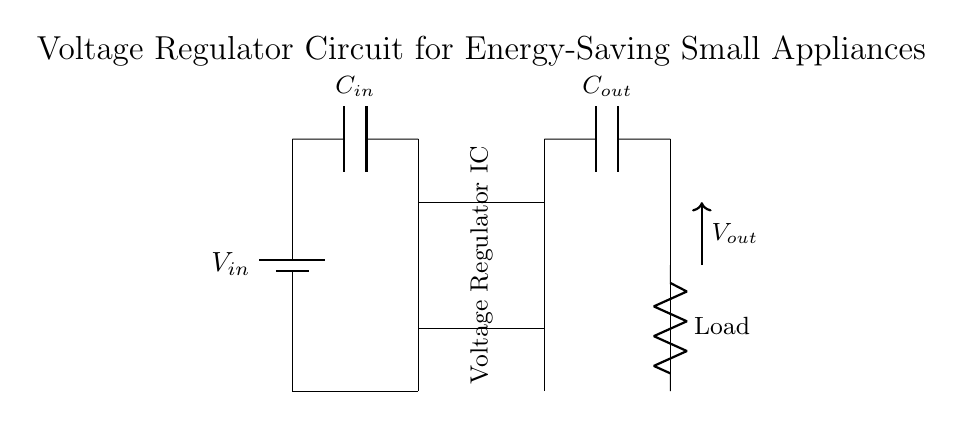What components are included in this circuit? The circuit includes a voltage regulator IC, an input capacitor, an output capacitor, and a load resistor. Each of these components serves a specific purpose in regulating voltage and ensuring stable operation of low power appliances.
Answer: voltage regulator IC, input capacitor, output capacitor, load resistor What is the purpose of the input capacitor? The input capacitor smooths out voltage fluctuations from the power source, providing a stable input voltage to the voltage regulator. Its role is essential for the performance and stability of the regulator circuit.
Answer: Smooth voltage fluctuations What are the voltage levels across the components? The input voltage is represented as V_in, while the output voltage is labeled as V_out. The exact values are not specified, but typically, V_out would be lower than V_in, depending on the regulator's specifications.
Answer: V_in, V_out How does this circuit contribute to energy-saving? The voltage regulator efficiently converts and stabilizes the input voltage to optimal levels for low power appliances, reducing energy waste associated with excessive voltage, thus contributing to energy savings.
Answer: Reduces energy waste Which component regulates the output voltage in the circuit? The voltage regulator IC is specifically designed to maintain a constant output voltage regardless of variations in input voltage or load conditions. This is its primary function in the circuit.
Answer: Voltage regulator IC What happens if the output capacitor fails? If the output capacitor fails, the circuit may experience increased voltage ripple at the output, leading to unstable performance of the connected load. This instability can result in the appliance malfunctioning or experiencing reduced efficiency.
Answer: Increased voltage ripple 